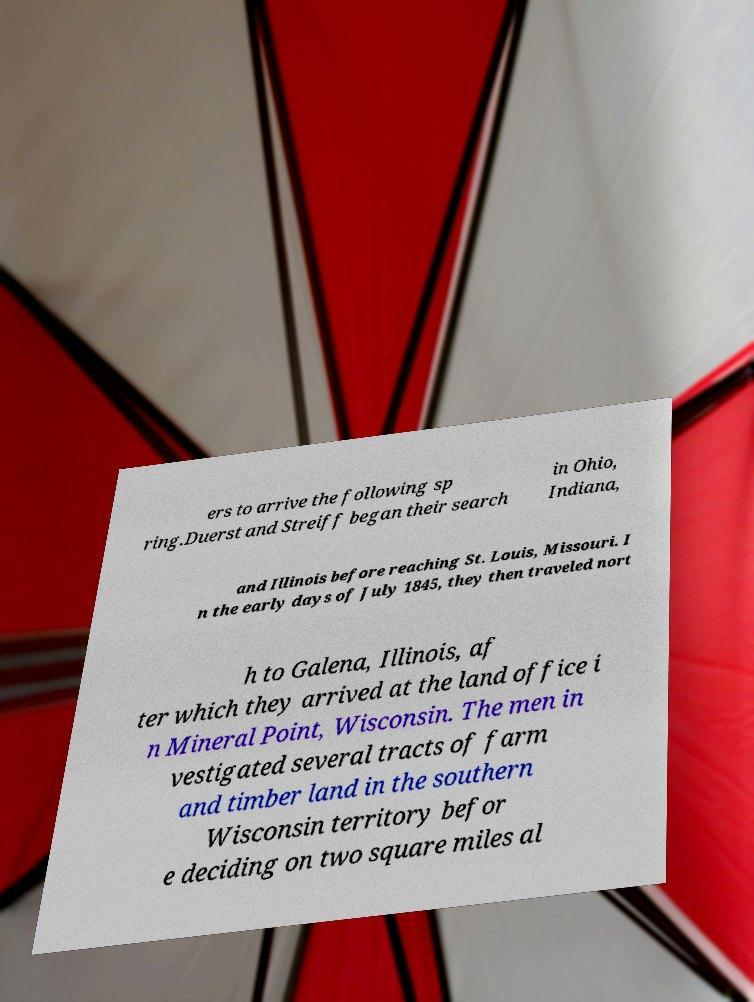For documentation purposes, I need the text within this image transcribed. Could you provide that? ers to arrive the following sp ring.Duerst and Streiff began their search in Ohio, Indiana, and Illinois before reaching St. Louis, Missouri. I n the early days of July 1845, they then traveled nort h to Galena, Illinois, af ter which they arrived at the land office i n Mineral Point, Wisconsin. The men in vestigated several tracts of farm and timber land in the southern Wisconsin territory befor e deciding on two square miles al 